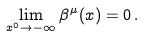<formula> <loc_0><loc_0><loc_500><loc_500>\lim _ { x ^ { 0 } \to - \infty } \beta ^ { \mu } ( x ) = 0 \, .</formula> 